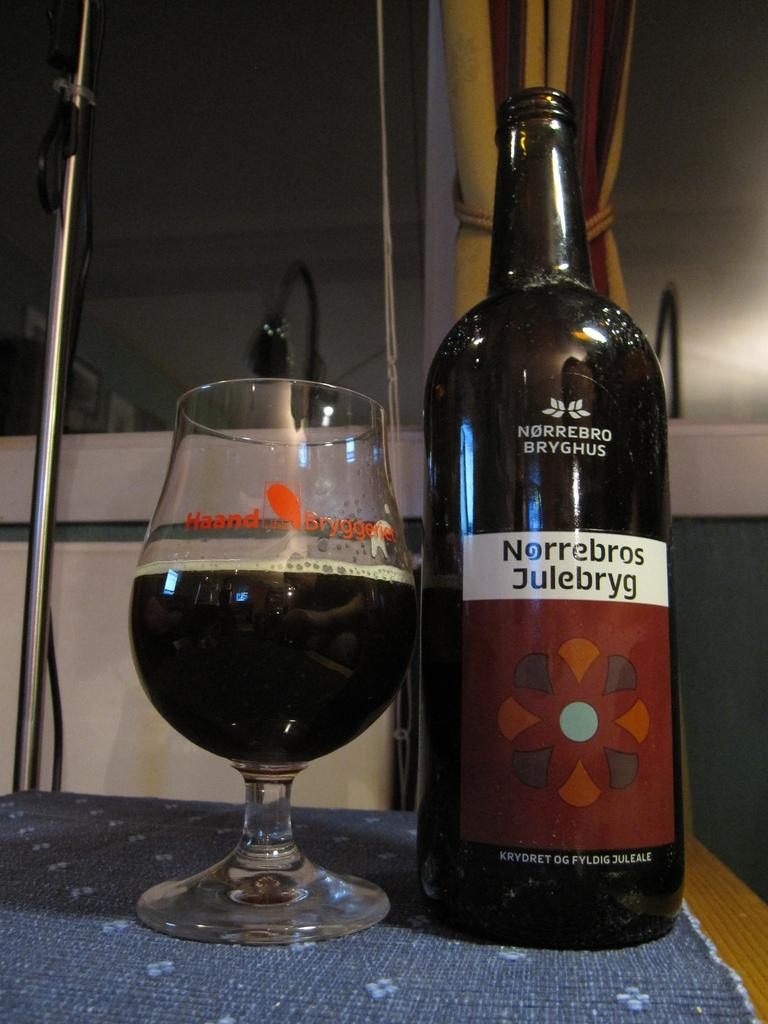<image>
Describe the image concisely. A half full glass is next to an open bottle of Norrebros Julebryg. 